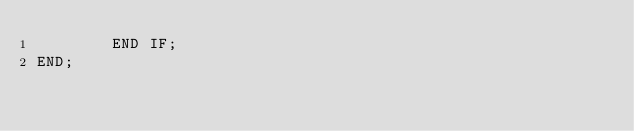Convert code to text. <code><loc_0><loc_0><loc_500><loc_500><_SQL_>		END IF;
END;</code> 